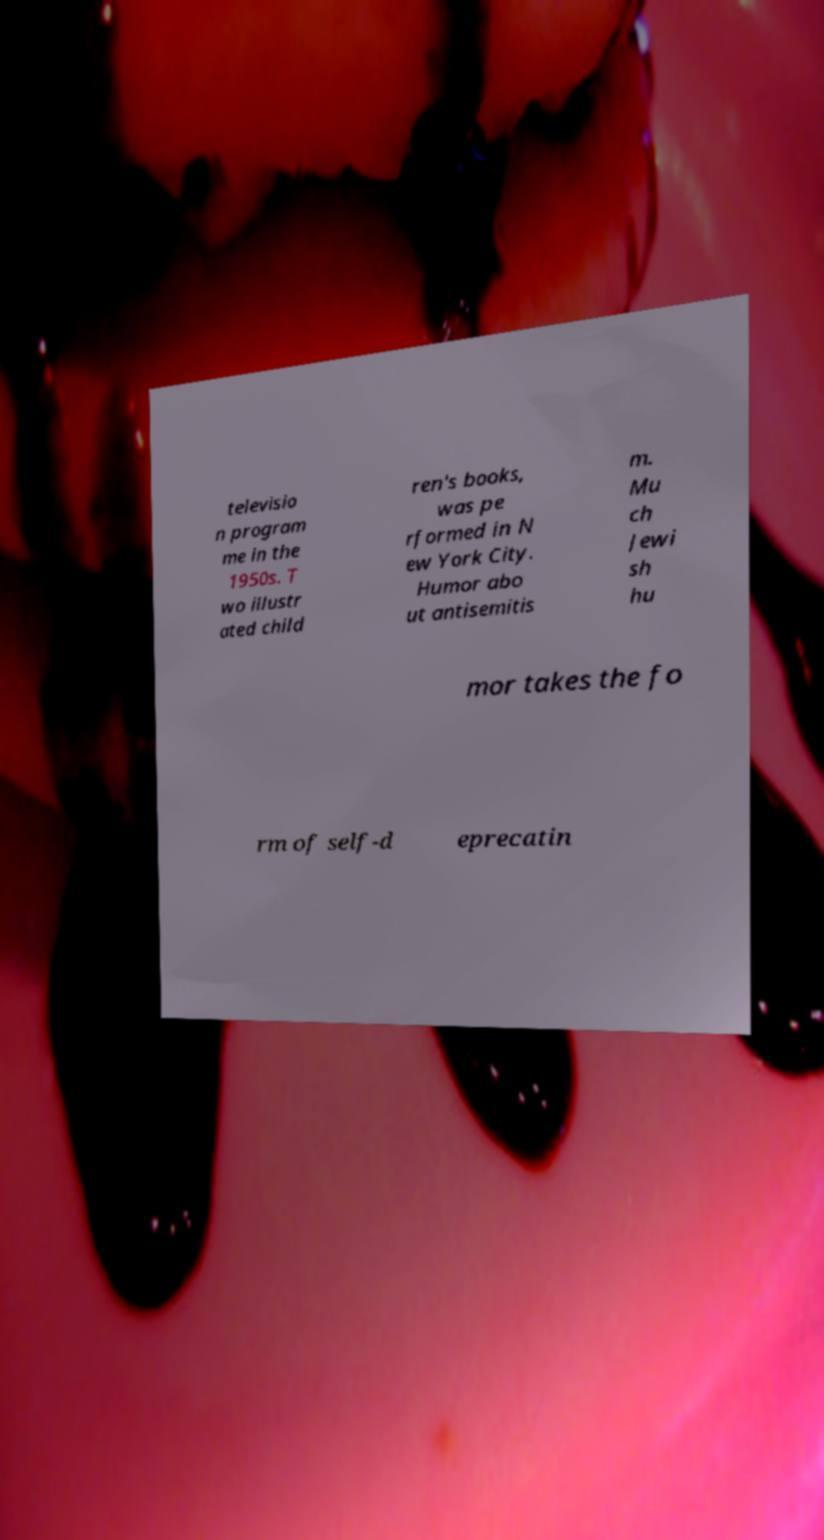Can you accurately transcribe the text from the provided image for me? televisio n program me in the 1950s. T wo illustr ated child ren's books, was pe rformed in N ew York City. Humor abo ut antisemitis m. Mu ch Jewi sh hu mor takes the fo rm of self-d eprecatin 